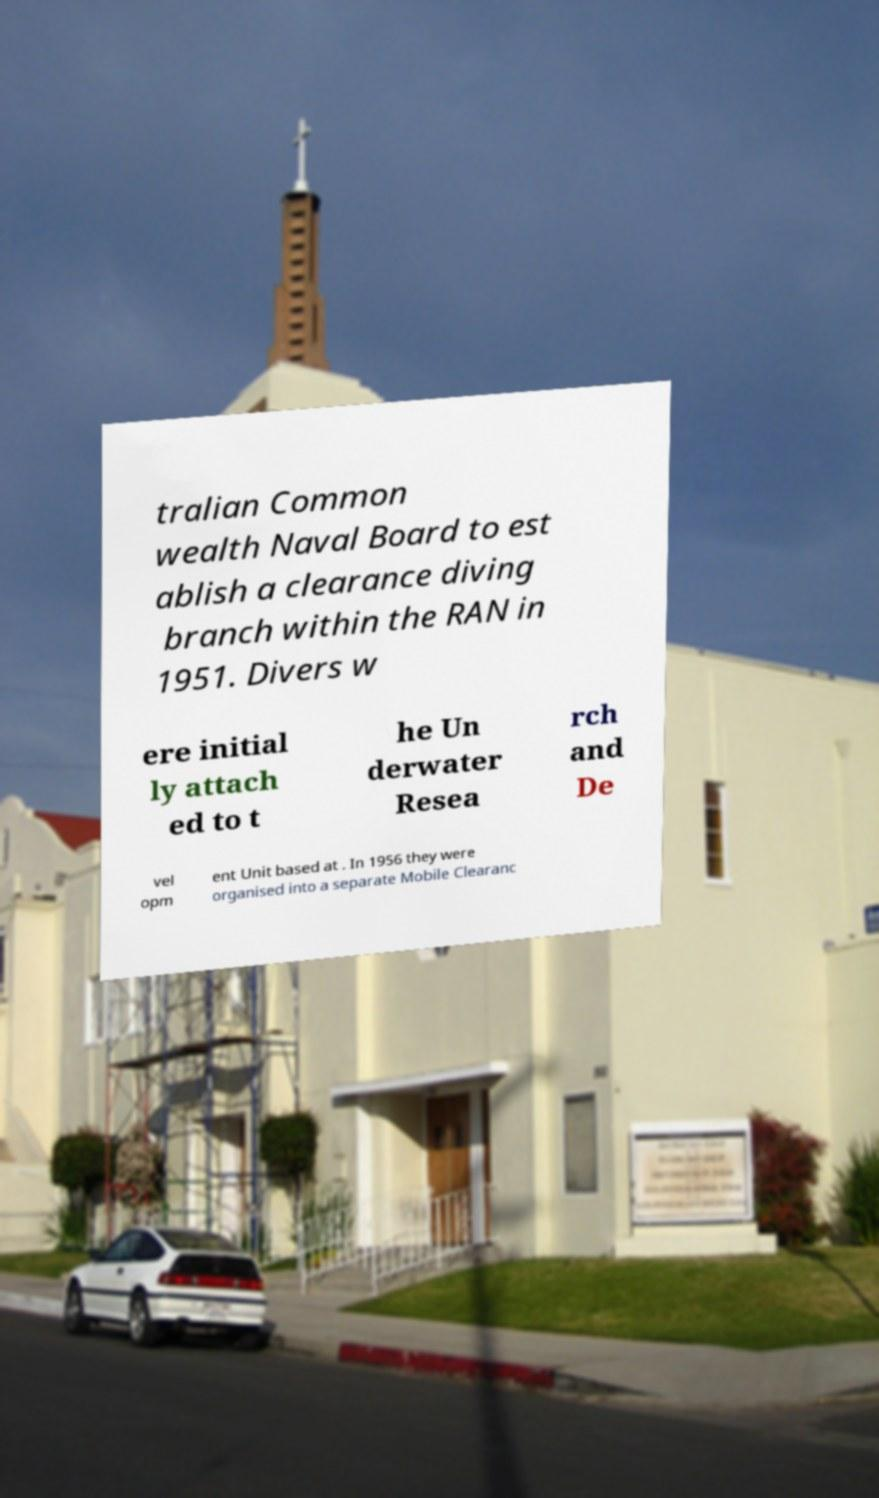Can you read and provide the text displayed in the image?This photo seems to have some interesting text. Can you extract and type it out for me? tralian Common wealth Naval Board to est ablish a clearance diving branch within the RAN in 1951. Divers w ere initial ly attach ed to t he Un derwater Resea rch and De vel opm ent Unit based at . In 1956 they were organised into a separate Mobile Clearanc 